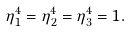Convert formula to latex. <formula><loc_0><loc_0><loc_500><loc_500>\eta _ { 1 } ^ { 4 } = \eta _ { 2 } ^ { 4 } = \eta _ { 3 } ^ { 4 } = 1 .</formula> 